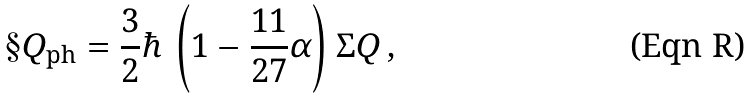<formula> <loc_0><loc_0><loc_500><loc_500>\S Q _ { \text {ph} } = \frac { 3 } { 2 } \hbar { \, } \left ( 1 - \frac { 1 1 } { 2 7 } \alpha \right ) \Sigma Q \, ,</formula> 